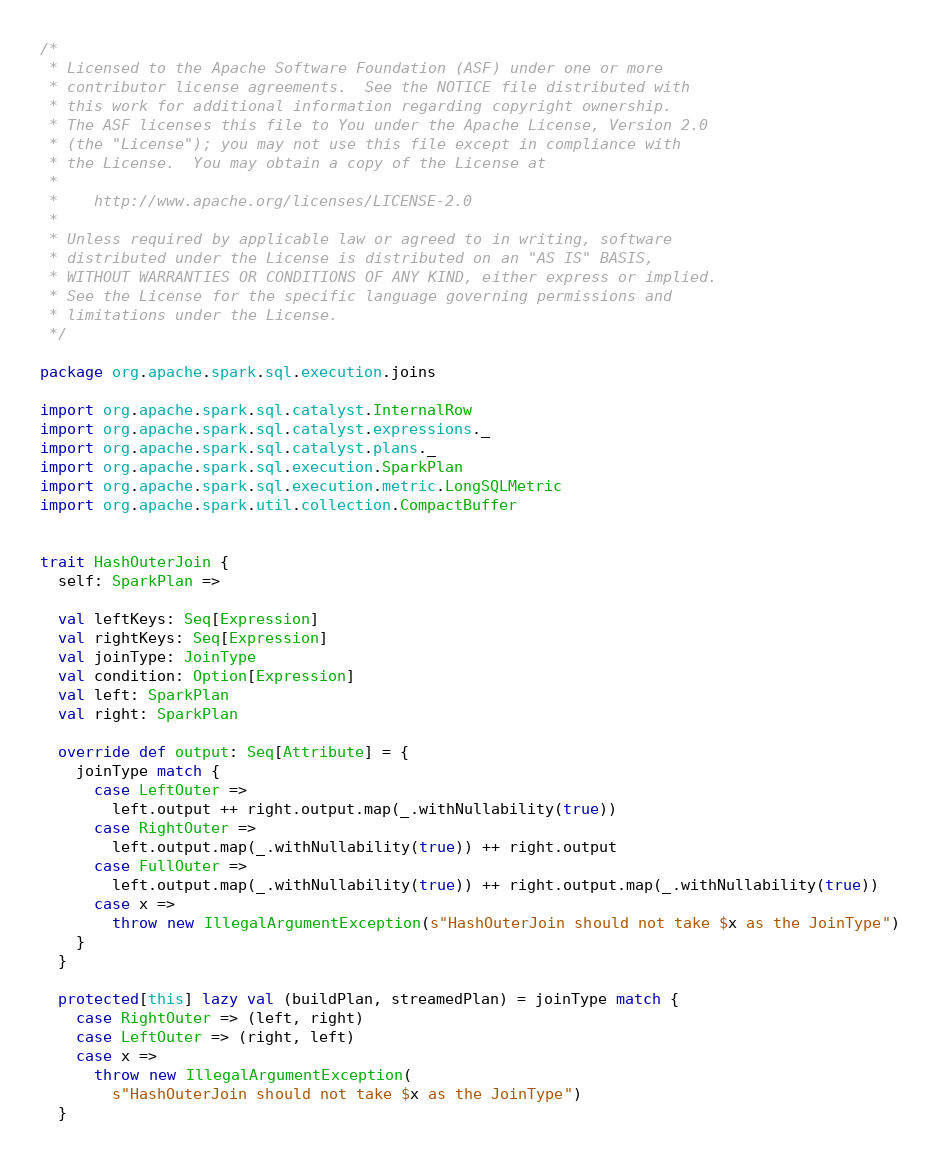<code> <loc_0><loc_0><loc_500><loc_500><_Scala_>/*
 * Licensed to the Apache Software Foundation (ASF) under one or more
 * contributor license agreements.  See the NOTICE file distributed with
 * this work for additional information regarding copyright ownership.
 * The ASF licenses this file to You under the Apache License, Version 2.0
 * (the "License"); you may not use this file except in compliance with
 * the License.  You may obtain a copy of the License at
 *
 *    http://www.apache.org/licenses/LICENSE-2.0
 *
 * Unless required by applicable law or agreed to in writing, software
 * distributed under the License is distributed on an "AS IS" BASIS,
 * WITHOUT WARRANTIES OR CONDITIONS OF ANY KIND, either express or implied.
 * See the License for the specific language governing permissions and
 * limitations under the License.
 */

package org.apache.spark.sql.execution.joins

import org.apache.spark.sql.catalyst.InternalRow
import org.apache.spark.sql.catalyst.expressions._
import org.apache.spark.sql.catalyst.plans._
import org.apache.spark.sql.execution.SparkPlan
import org.apache.spark.sql.execution.metric.LongSQLMetric
import org.apache.spark.util.collection.CompactBuffer


trait HashOuterJoin {
  self: SparkPlan =>

  val leftKeys: Seq[Expression]
  val rightKeys: Seq[Expression]
  val joinType: JoinType
  val condition: Option[Expression]
  val left: SparkPlan
  val right: SparkPlan

  override def output: Seq[Attribute] = {
    joinType match {
      case LeftOuter =>
        left.output ++ right.output.map(_.withNullability(true))
      case RightOuter =>
        left.output.map(_.withNullability(true)) ++ right.output
      case FullOuter =>
        left.output.map(_.withNullability(true)) ++ right.output.map(_.withNullability(true))
      case x =>
        throw new IllegalArgumentException(s"HashOuterJoin should not take $x as the JoinType")
    }
  }

  protected[this] lazy val (buildPlan, streamedPlan) = joinType match {
    case RightOuter => (left, right)
    case LeftOuter => (right, left)
    case x =>
      throw new IllegalArgumentException(
        s"HashOuterJoin should not take $x as the JoinType")
  }
</code> 